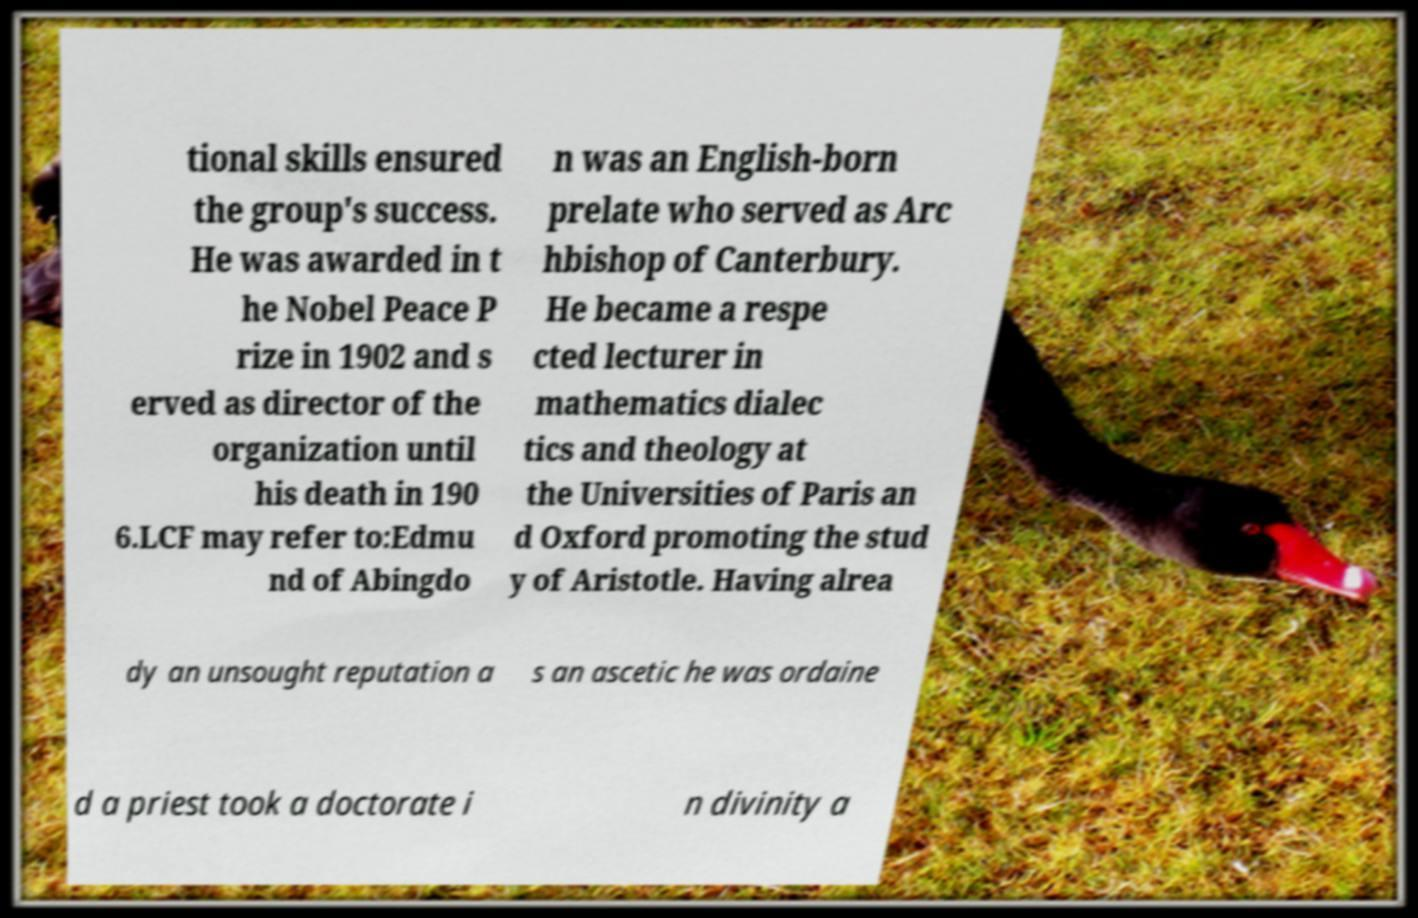There's text embedded in this image that I need extracted. Can you transcribe it verbatim? tional skills ensured the group's success. He was awarded in t he Nobel Peace P rize in 1902 and s erved as director of the organization until his death in 190 6.LCF may refer to:Edmu nd of Abingdo n was an English-born prelate who served as Arc hbishop of Canterbury. He became a respe cted lecturer in mathematics dialec tics and theology at the Universities of Paris an d Oxford promoting the stud y of Aristotle. Having alrea dy an unsought reputation a s an ascetic he was ordaine d a priest took a doctorate i n divinity a 